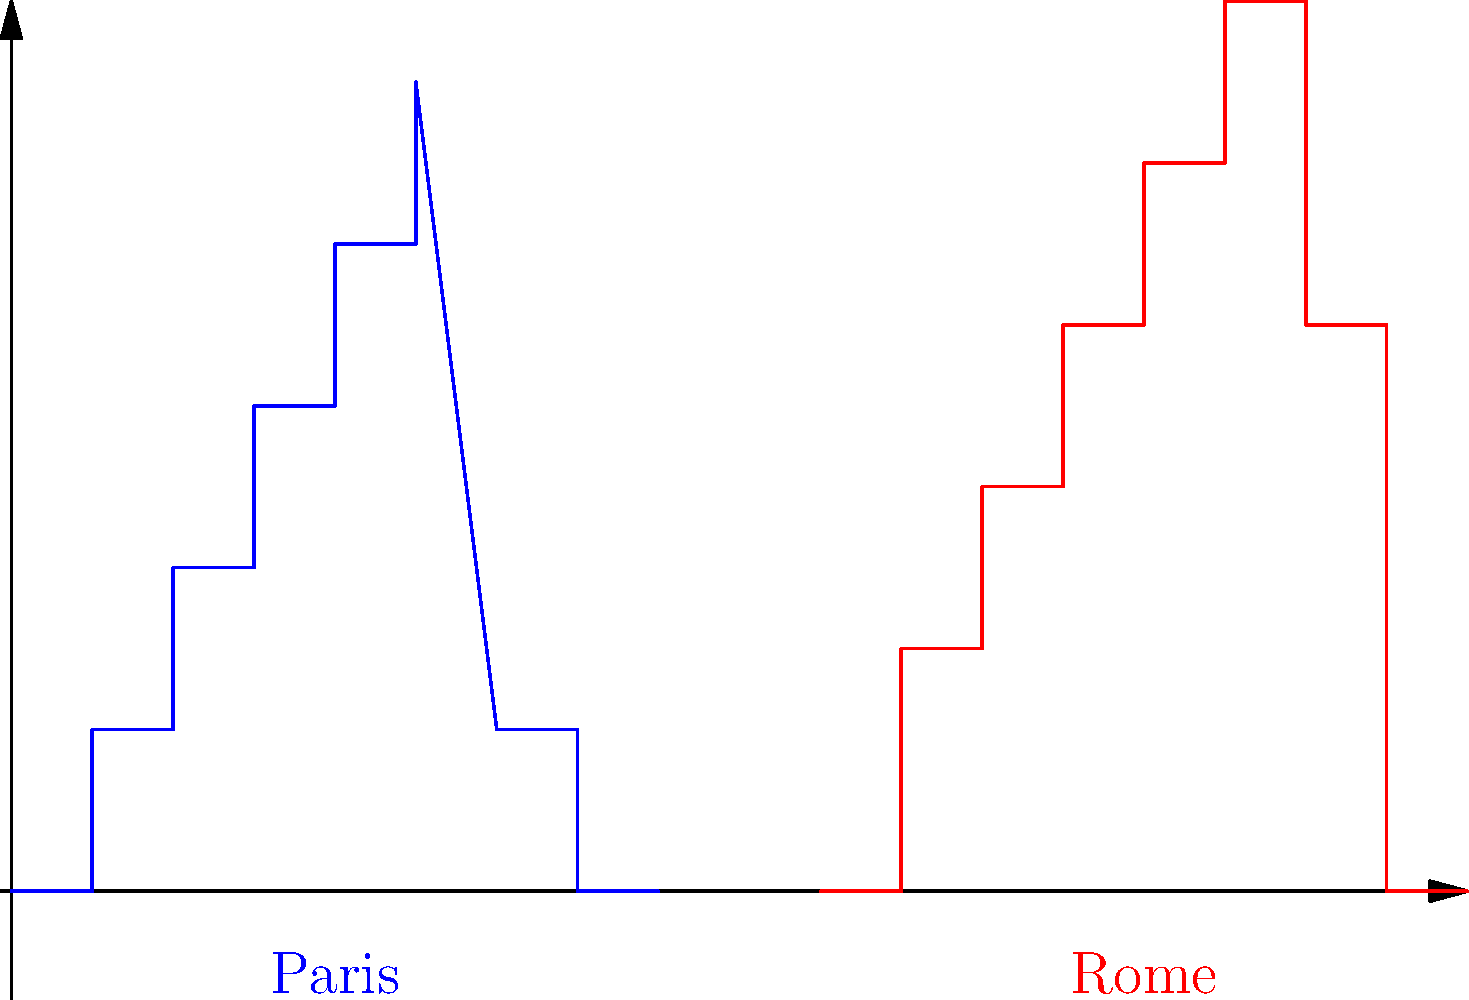Compare the skyline silhouettes of Paris and Rome shown in the diagram. Which architectural style is more prominently represented in the Paris skyline, and how does it differ from the architectural characteristics of Rome's skyline? To answer this question, we need to analyze the skyline silhouettes of both cities:

1. Paris skyline (blue):
   - Shows a more uniform height distribution
   - Has a prominent central peak (representing the Eiffel Tower)
   - Overall, presents a smoother, more geometric profile

2. Rome skyline (red):
   - Displays more variation in building heights
   - Features multiple domes and spires
   - Has a more irregular, organic profile

The Paris skyline prominently represents the Haussmannian style of architecture, characterized by:
   - Uniform building heights (regulations limited buildings to 5-6 stories)
   - Wide boulevards and open spaces (implied by the gaps between structures)
   - A focal point (the Eiffel Tower) rising above the uniform skyline

In contrast, Rome's skyline reflects its long architectural history, including:
   - Ancient Roman structures (lower, wider buildings)
   - Renaissance and Baroque elements (domes and spires)
   - Medieval towers and more recent additions creating a varied profile

The key difference lies in the planning approach:
   - Paris underwent a major urban renewal in the 19th century, resulting in a more planned, uniform appearance
   - Rome's development occurred organically over millennia, leading to a more diverse architectural landscape
Answer: Haussmannian style in Paris; more uniform and geometric compared to Rome's diverse, organic profile 